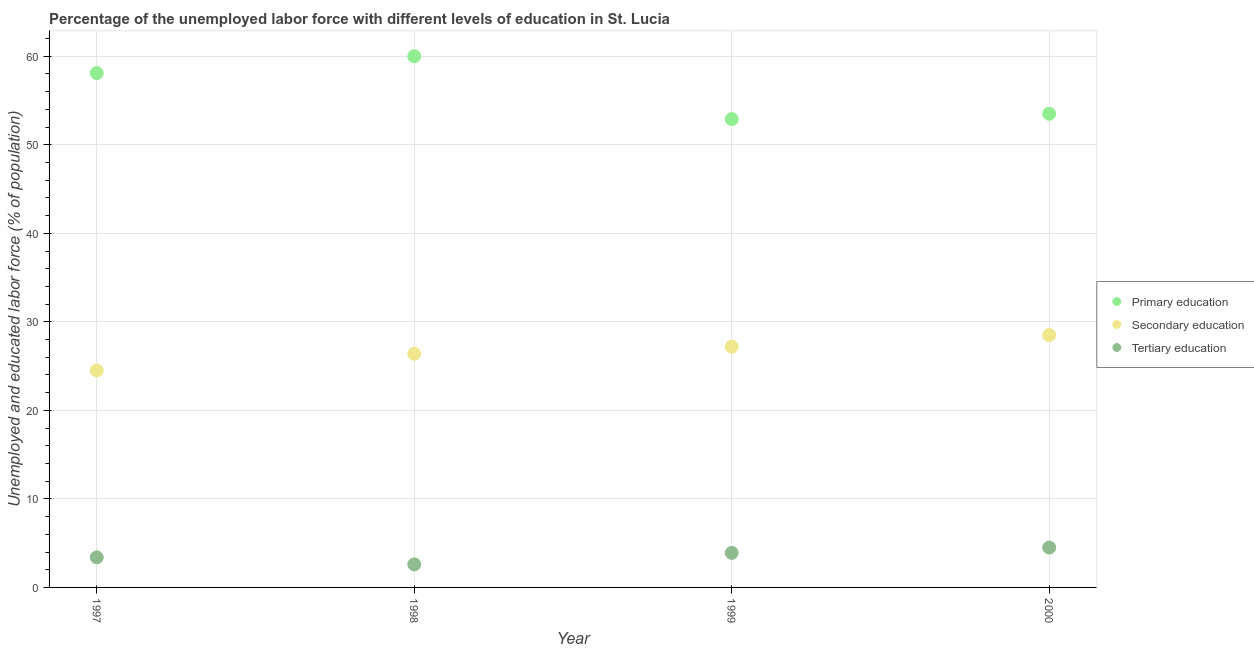Is the number of dotlines equal to the number of legend labels?
Offer a very short reply. Yes. What is the percentage of labor force who received primary education in 1999?
Your response must be concise. 52.9. Across all years, what is the maximum percentage of labor force who received primary education?
Offer a very short reply. 60. Across all years, what is the minimum percentage of labor force who received primary education?
Offer a terse response. 52.9. In which year was the percentage of labor force who received primary education maximum?
Offer a very short reply. 1998. In which year was the percentage of labor force who received tertiary education minimum?
Provide a succinct answer. 1998. What is the total percentage of labor force who received primary education in the graph?
Ensure brevity in your answer.  224.5. What is the difference between the percentage of labor force who received tertiary education in 1997 and that in 2000?
Your answer should be very brief. -1.1. What is the difference between the percentage of labor force who received primary education in 1999 and the percentage of labor force who received secondary education in 1998?
Offer a very short reply. 26.5. What is the average percentage of labor force who received tertiary education per year?
Offer a terse response. 3.6. In the year 1999, what is the difference between the percentage of labor force who received primary education and percentage of labor force who received tertiary education?
Offer a very short reply. 49. What is the ratio of the percentage of labor force who received secondary education in 1999 to that in 2000?
Offer a very short reply. 0.95. Is the percentage of labor force who received primary education in 1999 less than that in 2000?
Provide a short and direct response. Yes. Is the difference between the percentage of labor force who received primary education in 1998 and 2000 greater than the difference between the percentage of labor force who received secondary education in 1998 and 2000?
Offer a very short reply. Yes. What is the difference between the highest and the second highest percentage of labor force who received secondary education?
Your answer should be very brief. 1.3. What is the difference between the highest and the lowest percentage of labor force who received primary education?
Keep it short and to the point. 7.1. Is it the case that in every year, the sum of the percentage of labor force who received primary education and percentage of labor force who received secondary education is greater than the percentage of labor force who received tertiary education?
Keep it short and to the point. Yes. Is the percentage of labor force who received tertiary education strictly greater than the percentage of labor force who received primary education over the years?
Your response must be concise. No. Is the percentage of labor force who received secondary education strictly less than the percentage of labor force who received primary education over the years?
Give a very brief answer. Yes. How many dotlines are there?
Make the answer very short. 3. How many years are there in the graph?
Offer a terse response. 4. Where does the legend appear in the graph?
Keep it short and to the point. Center right. How many legend labels are there?
Make the answer very short. 3. What is the title of the graph?
Provide a succinct answer. Percentage of the unemployed labor force with different levels of education in St. Lucia. Does "Coal" appear as one of the legend labels in the graph?
Provide a short and direct response. No. What is the label or title of the X-axis?
Provide a short and direct response. Year. What is the label or title of the Y-axis?
Offer a very short reply. Unemployed and educated labor force (% of population). What is the Unemployed and educated labor force (% of population) of Primary education in 1997?
Your response must be concise. 58.1. What is the Unemployed and educated labor force (% of population) in Secondary education in 1997?
Your response must be concise. 24.5. What is the Unemployed and educated labor force (% of population) in Tertiary education in 1997?
Your answer should be very brief. 3.4. What is the Unemployed and educated labor force (% of population) in Primary education in 1998?
Your response must be concise. 60. What is the Unemployed and educated labor force (% of population) in Secondary education in 1998?
Ensure brevity in your answer.  26.4. What is the Unemployed and educated labor force (% of population) in Tertiary education in 1998?
Provide a succinct answer. 2.6. What is the Unemployed and educated labor force (% of population) of Primary education in 1999?
Give a very brief answer. 52.9. What is the Unemployed and educated labor force (% of population) of Secondary education in 1999?
Ensure brevity in your answer.  27.2. What is the Unemployed and educated labor force (% of population) of Tertiary education in 1999?
Provide a short and direct response. 3.9. What is the Unemployed and educated labor force (% of population) of Primary education in 2000?
Your answer should be very brief. 53.5. What is the Unemployed and educated labor force (% of population) of Tertiary education in 2000?
Provide a succinct answer. 4.5. Across all years, what is the maximum Unemployed and educated labor force (% of population) of Secondary education?
Your answer should be compact. 28.5. Across all years, what is the minimum Unemployed and educated labor force (% of population) of Primary education?
Your answer should be very brief. 52.9. Across all years, what is the minimum Unemployed and educated labor force (% of population) in Tertiary education?
Provide a succinct answer. 2.6. What is the total Unemployed and educated labor force (% of population) in Primary education in the graph?
Provide a short and direct response. 224.5. What is the total Unemployed and educated labor force (% of population) of Secondary education in the graph?
Your answer should be compact. 106.6. What is the difference between the Unemployed and educated labor force (% of population) in Primary education in 1997 and that in 2000?
Offer a very short reply. 4.6. What is the difference between the Unemployed and educated labor force (% of population) in Tertiary education in 1998 and that in 1999?
Make the answer very short. -1.3. What is the difference between the Unemployed and educated labor force (% of population) in Primary education in 1998 and that in 2000?
Your answer should be very brief. 6.5. What is the difference between the Unemployed and educated labor force (% of population) of Tertiary education in 1998 and that in 2000?
Your answer should be very brief. -1.9. What is the difference between the Unemployed and educated labor force (% of population) of Primary education in 1999 and that in 2000?
Your answer should be very brief. -0.6. What is the difference between the Unemployed and educated labor force (% of population) of Primary education in 1997 and the Unemployed and educated labor force (% of population) of Secondary education in 1998?
Provide a short and direct response. 31.7. What is the difference between the Unemployed and educated labor force (% of population) of Primary education in 1997 and the Unemployed and educated labor force (% of population) of Tertiary education in 1998?
Ensure brevity in your answer.  55.5. What is the difference between the Unemployed and educated labor force (% of population) in Secondary education in 1997 and the Unemployed and educated labor force (% of population) in Tertiary education in 1998?
Make the answer very short. 21.9. What is the difference between the Unemployed and educated labor force (% of population) in Primary education in 1997 and the Unemployed and educated labor force (% of population) in Secondary education in 1999?
Offer a very short reply. 30.9. What is the difference between the Unemployed and educated labor force (% of population) in Primary education in 1997 and the Unemployed and educated labor force (% of population) in Tertiary education in 1999?
Provide a succinct answer. 54.2. What is the difference between the Unemployed and educated labor force (% of population) of Secondary education in 1997 and the Unemployed and educated labor force (% of population) of Tertiary education in 1999?
Give a very brief answer. 20.6. What is the difference between the Unemployed and educated labor force (% of population) of Primary education in 1997 and the Unemployed and educated labor force (% of population) of Secondary education in 2000?
Ensure brevity in your answer.  29.6. What is the difference between the Unemployed and educated labor force (% of population) of Primary education in 1997 and the Unemployed and educated labor force (% of population) of Tertiary education in 2000?
Your answer should be very brief. 53.6. What is the difference between the Unemployed and educated labor force (% of population) of Primary education in 1998 and the Unemployed and educated labor force (% of population) of Secondary education in 1999?
Keep it short and to the point. 32.8. What is the difference between the Unemployed and educated labor force (% of population) in Primary education in 1998 and the Unemployed and educated labor force (% of population) in Tertiary education in 1999?
Give a very brief answer. 56.1. What is the difference between the Unemployed and educated labor force (% of population) in Primary education in 1998 and the Unemployed and educated labor force (% of population) in Secondary education in 2000?
Offer a terse response. 31.5. What is the difference between the Unemployed and educated labor force (% of population) of Primary education in 1998 and the Unemployed and educated labor force (% of population) of Tertiary education in 2000?
Your answer should be compact. 55.5. What is the difference between the Unemployed and educated labor force (% of population) in Secondary education in 1998 and the Unemployed and educated labor force (% of population) in Tertiary education in 2000?
Provide a short and direct response. 21.9. What is the difference between the Unemployed and educated labor force (% of population) in Primary education in 1999 and the Unemployed and educated labor force (% of population) in Secondary education in 2000?
Give a very brief answer. 24.4. What is the difference between the Unemployed and educated labor force (% of population) of Primary education in 1999 and the Unemployed and educated labor force (% of population) of Tertiary education in 2000?
Your response must be concise. 48.4. What is the difference between the Unemployed and educated labor force (% of population) of Secondary education in 1999 and the Unemployed and educated labor force (% of population) of Tertiary education in 2000?
Keep it short and to the point. 22.7. What is the average Unemployed and educated labor force (% of population) in Primary education per year?
Provide a short and direct response. 56.12. What is the average Unemployed and educated labor force (% of population) in Secondary education per year?
Give a very brief answer. 26.65. In the year 1997, what is the difference between the Unemployed and educated labor force (% of population) of Primary education and Unemployed and educated labor force (% of population) of Secondary education?
Give a very brief answer. 33.6. In the year 1997, what is the difference between the Unemployed and educated labor force (% of population) in Primary education and Unemployed and educated labor force (% of population) in Tertiary education?
Ensure brevity in your answer.  54.7. In the year 1997, what is the difference between the Unemployed and educated labor force (% of population) of Secondary education and Unemployed and educated labor force (% of population) of Tertiary education?
Offer a very short reply. 21.1. In the year 1998, what is the difference between the Unemployed and educated labor force (% of population) of Primary education and Unemployed and educated labor force (% of population) of Secondary education?
Offer a very short reply. 33.6. In the year 1998, what is the difference between the Unemployed and educated labor force (% of population) in Primary education and Unemployed and educated labor force (% of population) in Tertiary education?
Offer a terse response. 57.4. In the year 1998, what is the difference between the Unemployed and educated labor force (% of population) in Secondary education and Unemployed and educated labor force (% of population) in Tertiary education?
Offer a very short reply. 23.8. In the year 1999, what is the difference between the Unemployed and educated labor force (% of population) of Primary education and Unemployed and educated labor force (% of population) of Secondary education?
Give a very brief answer. 25.7. In the year 1999, what is the difference between the Unemployed and educated labor force (% of population) of Secondary education and Unemployed and educated labor force (% of population) of Tertiary education?
Your response must be concise. 23.3. In the year 2000, what is the difference between the Unemployed and educated labor force (% of population) of Primary education and Unemployed and educated labor force (% of population) of Secondary education?
Ensure brevity in your answer.  25. In the year 2000, what is the difference between the Unemployed and educated labor force (% of population) in Primary education and Unemployed and educated labor force (% of population) in Tertiary education?
Ensure brevity in your answer.  49. In the year 2000, what is the difference between the Unemployed and educated labor force (% of population) of Secondary education and Unemployed and educated labor force (% of population) of Tertiary education?
Make the answer very short. 24. What is the ratio of the Unemployed and educated labor force (% of population) in Primary education in 1997 to that in 1998?
Ensure brevity in your answer.  0.97. What is the ratio of the Unemployed and educated labor force (% of population) in Secondary education in 1997 to that in 1998?
Keep it short and to the point. 0.93. What is the ratio of the Unemployed and educated labor force (% of population) of Tertiary education in 1997 to that in 1998?
Offer a very short reply. 1.31. What is the ratio of the Unemployed and educated labor force (% of population) in Primary education in 1997 to that in 1999?
Provide a short and direct response. 1.1. What is the ratio of the Unemployed and educated labor force (% of population) in Secondary education in 1997 to that in 1999?
Provide a short and direct response. 0.9. What is the ratio of the Unemployed and educated labor force (% of population) in Tertiary education in 1997 to that in 1999?
Keep it short and to the point. 0.87. What is the ratio of the Unemployed and educated labor force (% of population) in Primary education in 1997 to that in 2000?
Ensure brevity in your answer.  1.09. What is the ratio of the Unemployed and educated labor force (% of population) of Secondary education in 1997 to that in 2000?
Keep it short and to the point. 0.86. What is the ratio of the Unemployed and educated labor force (% of population) of Tertiary education in 1997 to that in 2000?
Your answer should be compact. 0.76. What is the ratio of the Unemployed and educated labor force (% of population) of Primary education in 1998 to that in 1999?
Provide a short and direct response. 1.13. What is the ratio of the Unemployed and educated labor force (% of population) in Secondary education in 1998 to that in 1999?
Your response must be concise. 0.97. What is the ratio of the Unemployed and educated labor force (% of population) of Primary education in 1998 to that in 2000?
Make the answer very short. 1.12. What is the ratio of the Unemployed and educated labor force (% of population) of Secondary education in 1998 to that in 2000?
Provide a succinct answer. 0.93. What is the ratio of the Unemployed and educated labor force (% of population) of Tertiary education in 1998 to that in 2000?
Your answer should be very brief. 0.58. What is the ratio of the Unemployed and educated labor force (% of population) in Primary education in 1999 to that in 2000?
Make the answer very short. 0.99. What is the ratio of the Unemployed and educated labor force (% of population) of Secondary education in 1999 to that in 2000?
Offer a very short reply. 0.95. What is the ratio of the Unemployed and educated labor force (% of population) of Tertiary education in 1999 to that in 2000?
Keep it short and to the point. 0.87. What is the difference between the highest and the second highest Unemployed and educated labor force (% of population) in Primary education?
Offer a very short reply. 1.9. What is the difference between the highest and the second highest Unemployed and educated labor force (% of population) of Tertiary education?
Make the answer very short. 0.6. What is the difference between the highest and the lowest Unemployed and educated labor force (% of population) in Primary education?
Provide a succinct answer. 7.1. What is the difference between the highest and the lowest Unemployed and educated labor force (% of population) in Tertiary education?
Make the answer very short. 1.9. 